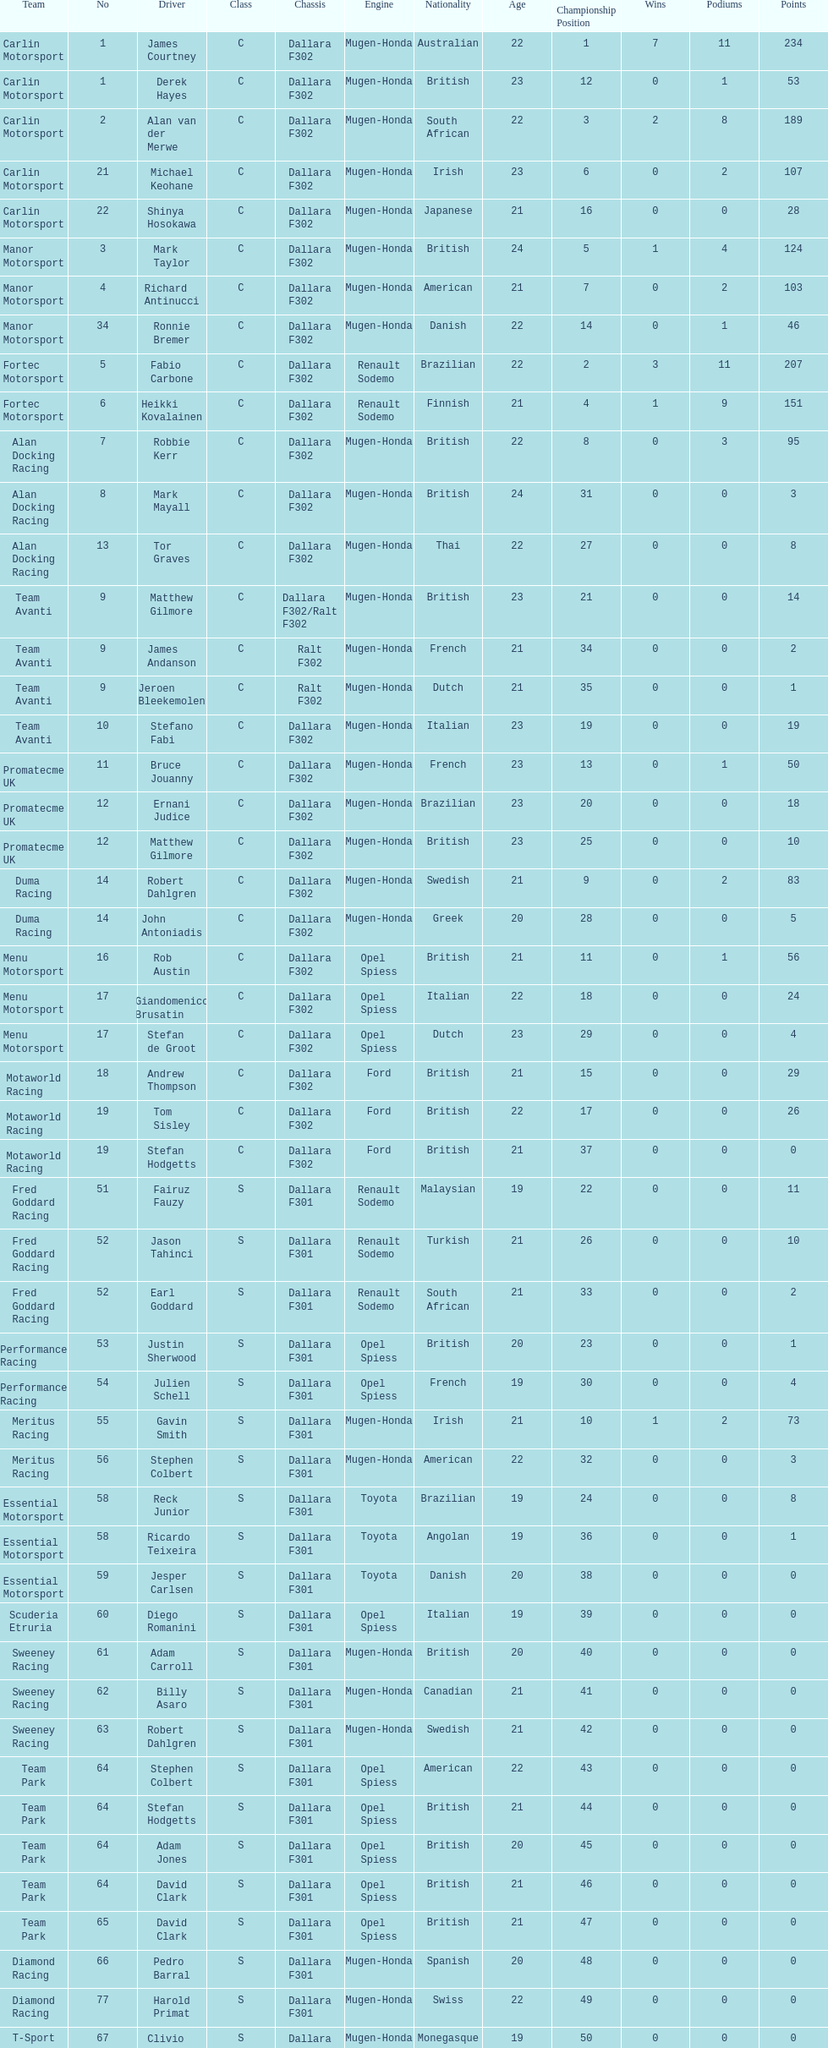What is the total number of class c (championship) teams? 21. 